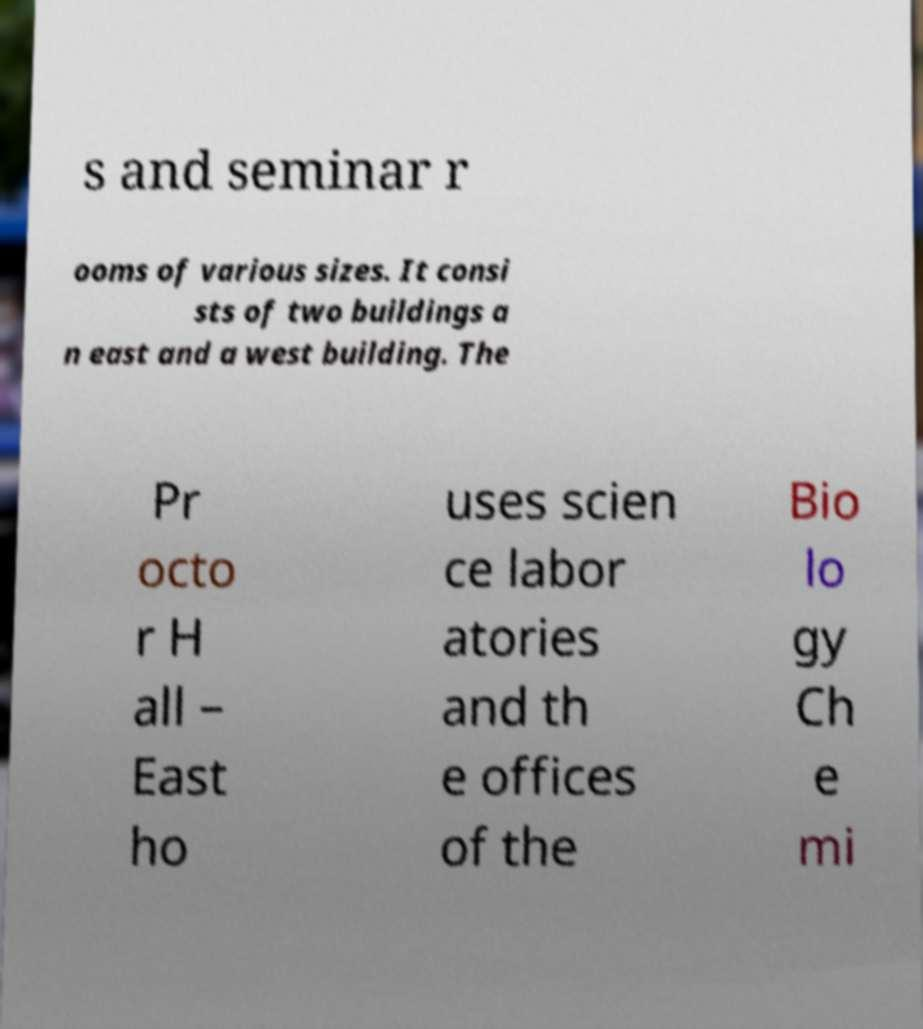What messages or text are displayed in this image? I need them in a readable, typed format. s and seminar r ooms of various sizes. It consi sts of two buildings a n east and a west building. The Pr octo r H all – East ho uses scien ce labor atories and th e offices of the Bio lo gy Ch e mi 